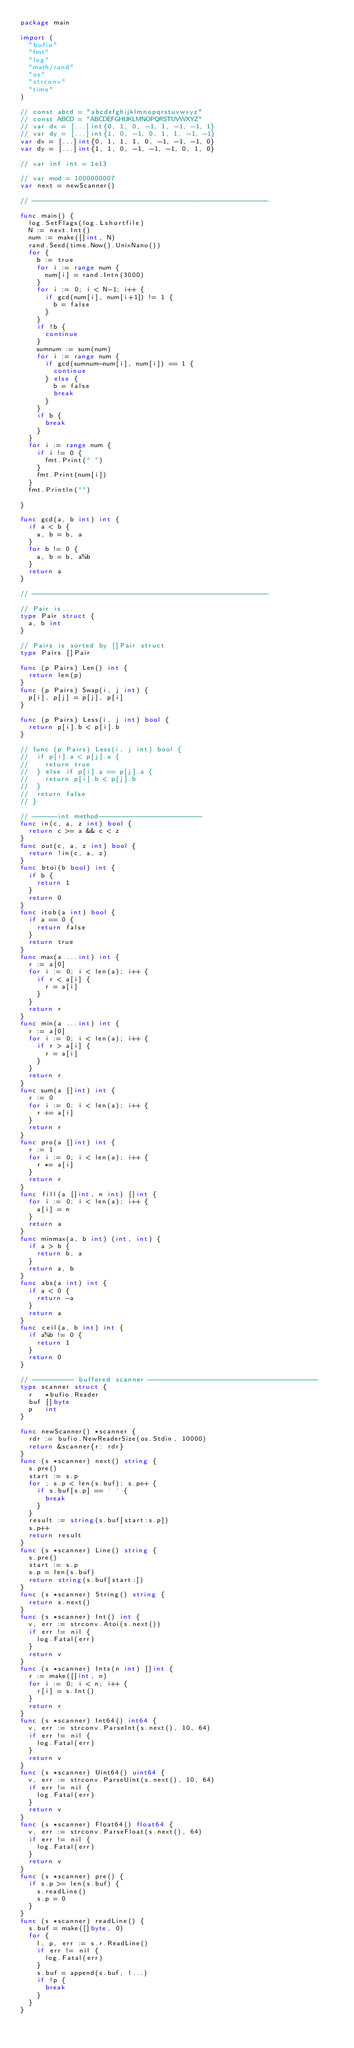<code> <loc_0><loc_0><loc_500><loc_500><_Go_>package main

import (
	"bufio"
	"fmt"
	"log"
	"math/rand"
	"os"
	"strconv"
	"time"
)

// const abcd = "abcdefghijklmnopqrstuvwxyz"
// const ABCD = "ABCDEFGHIJKLMNOPQRSTUVWXYZ"
// var dx = [...]int{0, 1, 0, -1, 1, -1, -1, 1}
// var dy = [...]int{1, 0, -1, 0, 1, 1, -1, -1}
var dx = [...]int{0, 1, 1, 1, 0, -1, -1, -1, 0}
var dy = [...]int{1, 1, 0, -1, -1, -1, 0, 1, 0}

// var inf int = 1e13

// var mod = 1000000007
var next = newScanner()

// ---------------------------------------------------------

func main() {
	log.SetFlags(log.Lshortfile)
	N := next.Int()
	num := make([]int, N)
	rand.Seed(time.Now().UnixNano())
	for {
		b := true
		for i := range num {
			num[i] = rand.Intn(3000)
		}
		for i := 0; i < N-1; i++ {
			if gcd(num[i], num[i+1]) != 1 {
				b = false
			}
		}
		if !b {
			continue
		}
		sumnum := sum(num)
		for i := range num {
			if gcd(sumnum-num[i], num[i]) == 1 {
				continue
			} else {
				b = false
				break
			}
		}
		if b {
			break
		}
	}
	for i := range num {
		if i != 0 {
			fmt.Print(" ")
		}
		fmt.Print(num[i])
	}
	fmt.Println("")

}

func gcd(a, b int) int {
	if a < b {
		a, b = b, a
	}
	for b != 0 {
		a, b = b, a%b
	}
	return a
}

// ---------------------------------------------------------

// Pair is...
type Pair struct {
	a, b int
}

// Pairs is sorted by []Pair struct
type Pairs []Pair

func (p Pairs) Len() int {
	return len(p)
}
func (p Pairs) Swap(i, j int) {
	p[i], p[j] = p[j], p[i]
}

func (p Pairs) Less(i, j int) bool {
	return p[i].b < p[i].b
}

// func (p Pairs) Less(i, j int) bool {
// 	if p[i].a < p[j].a {
// 		return true
// 	} else if p[i].a == p[j].a {
// 		return p[i].b < p[j].b
// 	}
// 	return false
// }

// ------int method-------------------------
func in(c, a, z int) bool {
	return c >= a && c < z
}
func out(c, a, z int) bool {
	return !in(c, a, z)
}
func btoi(b bool) int {
	if b {
		return 1
	}
	return 0
}
func itob(a int) bool {
	if a == 0 {
		return false
	}
	return true
}
func max(a ...int) int {
	r := a[0]
	for i := 0; i < len(a); i++ {
		if r < a[i] {
			r = a[i]
		}
	}
	return r
}
func min(a ...int) int {
	r := a[0]
	for i := 0; i < len(a); i++ {
		if r > a[i] {
			r = a[i]
		}
	}
	return r
}
func sum(a []int) int {
	r := 0
	for i := 0; i < len(a); i++ {
		r += a[i]
	}
	return r
}
func pro(a []int) int {
	r := 1
	for i := 0; i < len(a); i++ {
		r *= a[i]
	}
	return r
}
func fill(a []int, n int) []int {
	for i := 0; i < len(a); i++ {
		a[i] = n
	}
	return a
}
func minmax(a, b int) (int, int) {
	if a > b {
		return b, a
	}
	return a, b
}
func abs(a int) int {
	if a < 0 {
		return -a
	}
	return a
}
func ceil(a, b int) int {
	if a%b != 0 {
		return 1
	}
	return 0
}

// ---------- buffered scanner -----------------------------------------
type scanner struct {
	r   *bufio.Reader
	buf []byte
	p   int
}

func newScanner() *scanner {
	rdr := bufio.NewReaderSize(os.Stdin, 10000)
	return &scanner{r: rdr}
}
func (s *scanner) next() string {
	s.pre()
	start := s.p
	for ; s.p < len(s.buf); s.p++ {
		if s.buf[s.p] == ' ' {
			break
		}
	}
	result := string(s.buf[start:s.p])
	s.p++
	return result
}
func (s *scanner) Line() string {
	s.pre()
	start := s.p
	s.p = len(s.buf)
	return string(s.buf[start:])
}
func (s *scanner) String() string {
	return s.next()
}
func (s *scanner) Int() int {
	v, err := strconv.Atoi(s.next())
	if err != nil {
		log.Fatal(err)
	}
	return v
}
func (s *scanner) Ints(n int) []int {
	r := make([]int, n)
	for i := 0; i < n; i++ {
		r[i] = s.Int()
	}
	return r
}
func (s *scanner) Int64() int64 {
	v, err := strconv.ParseInt(s.next(), 10, 64)
	if err != nil {
		log.Fatal(err)
	}
	return v
}
func (s *scanner) Uint64() uint64 {
	v, err := strconv.ParseUint(s.next(), 10, 64)
	if err != nil {
		log.Fatal(err)
	}
	return v
}
func (s *scanner) Float64() float64 {
	v, err := strconv.ParseFloat(s.next(), 64)
	if err != nil {
		log.Fatal(err)
	}
	return v
}
func (s *scanner) pre() {
	if s.p >= len(s.buf) {
		s.readLine()
		s.p = 0
	}
}
func (s *scanner) readLine() {
	s.buf = make([]byte, 0)
	for {
		l, p, err := s.r.ReadLine()
		if err != nil {
			log.Fatal(err)
		}
		s.buf = append(s.buf, l...)
		if !p {
			break
		}
	}
}</code> 